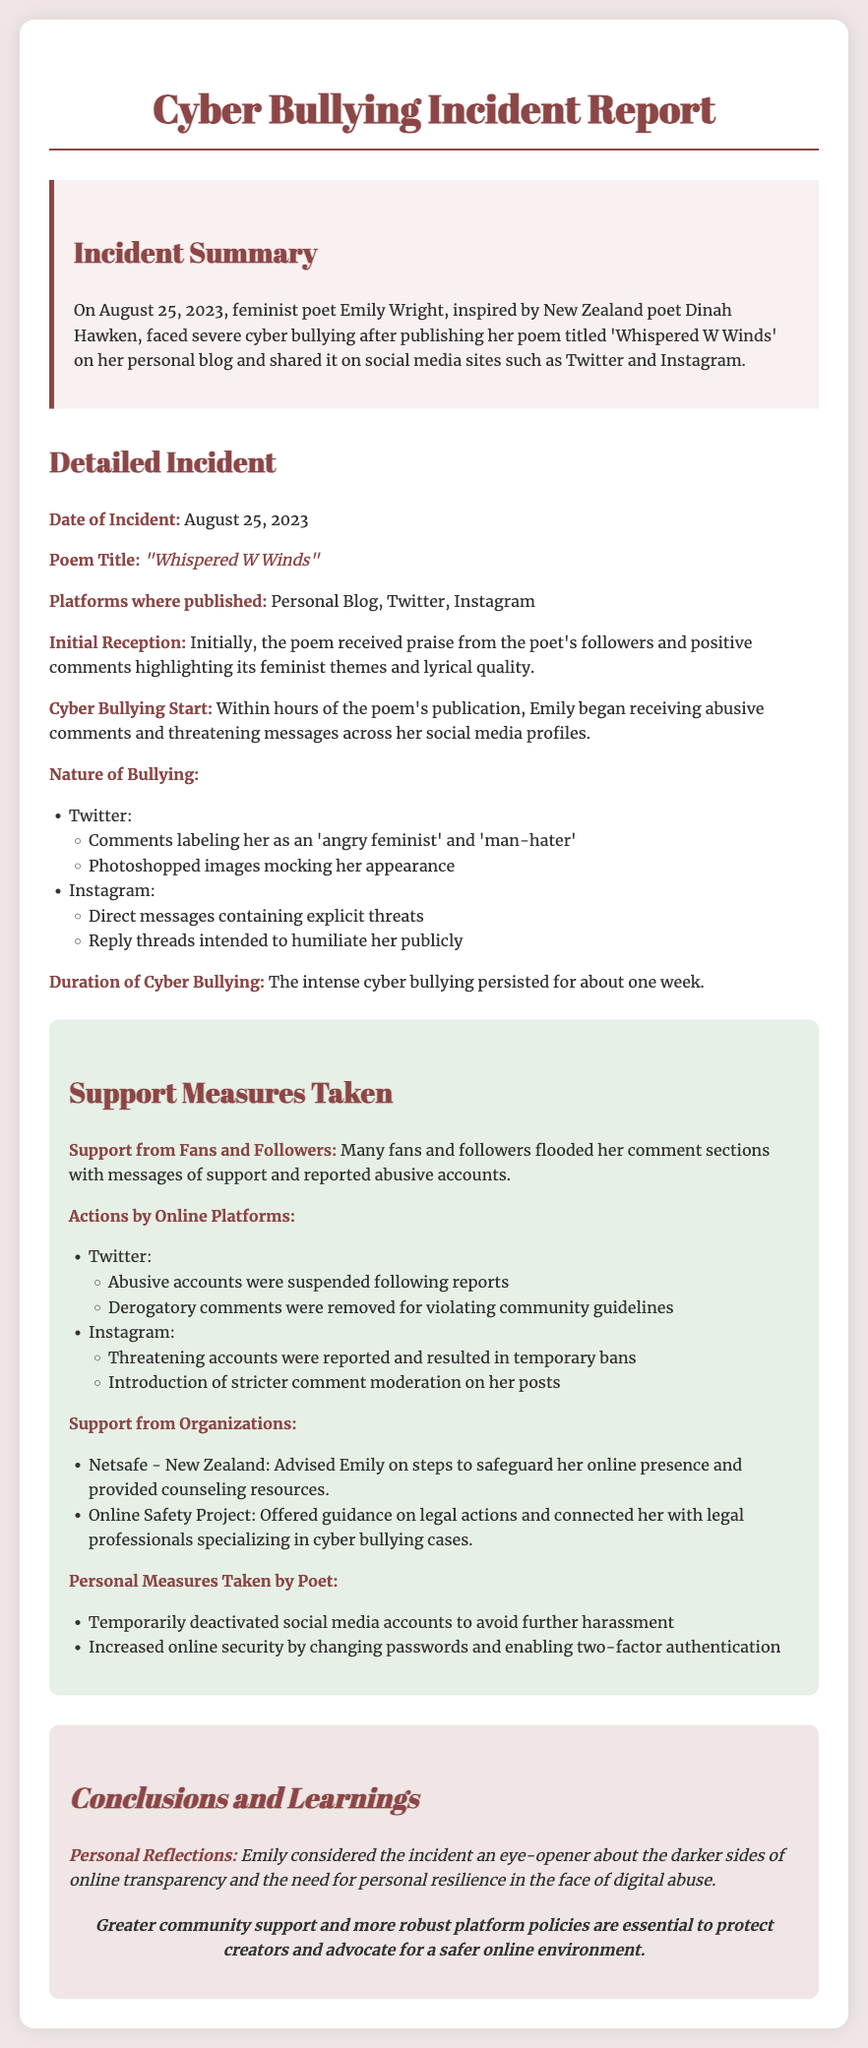What is the date of the incident? The date of the incident is mentioned explicitly in the document as August 25, 2023.
Answer: August 25, 2023 What is the title of the poem? The title of the poem is given in the detailed incident section, which is "Whispered W Winds".
Answer: "Whispered W Winds" Which platforms were used for publishing? The platforms where the poem was published are listed in the detailed incident section as Personal Blog, Twitter, and Instagram.
Answer: Personal Blog, Twitter, Instagram How long did the cyber bullying last? The document states that the intense cyber bullying persisted for about one week.
Answer: About one week What supportive action did fans take? Fans and followers flooded her comment sections with messages of support and reported abusive accounts, as noted in the support measures section.
Answer: Messages of support and reported abusive accounts Which organization advised Emily on online safety? The organization that advised Emily is mentioned as Netsafe - New Zealand.
Answer: Netsafe - New Zealand What type of comments were removed on Twitter? The document refers to derogatory comments that were removed for violating community guidelines on Twitter.
Answer: Derogatory comments What reflections did Emily have after the incident? In the conclusions section, it is stated that Emily considered the incident an eye-opener about online transparency and the need for personal resilience.
Answer: An eye-opener about online transparency and personal resilience 